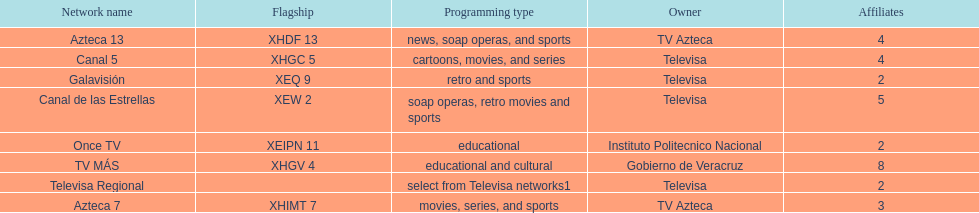Which owner has the most networks? Televisa. 